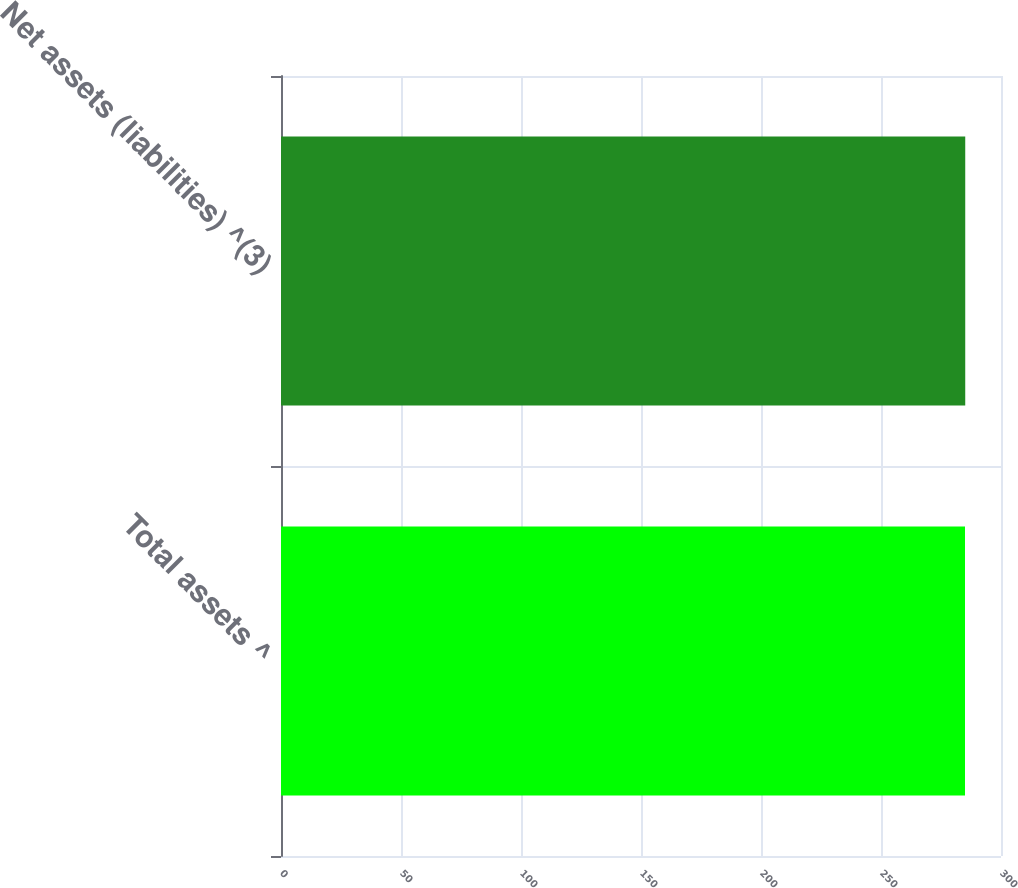<chart> <loc_0><loc_0><loc_500><loc_500><bar_chart><fcel>Total assets ^<fcel>Net assets (liabilities) ^(3)<nl><fcel>285<fcel>285.1<nl></chart> 